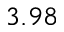<formula> <loc_0><loc_0><loc_500><loc_500>3 . 9 8</formula> 